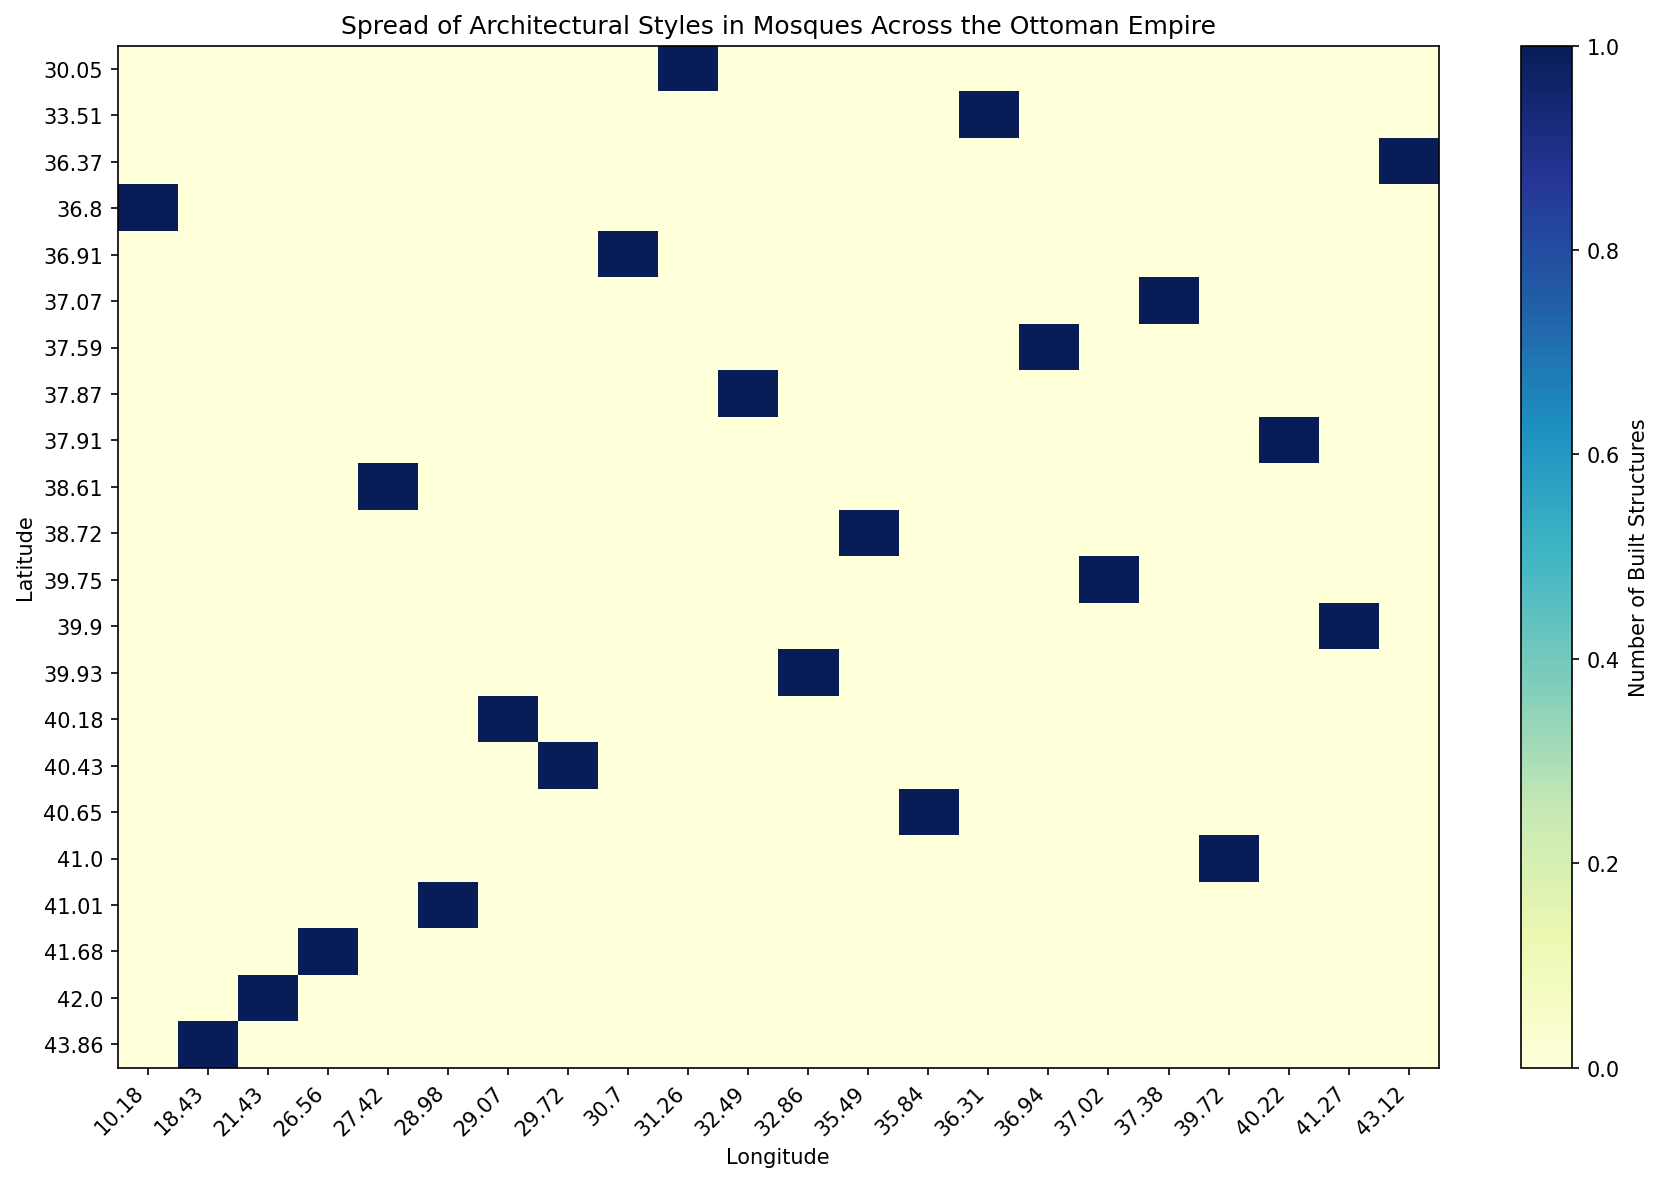What's the city with the highest number of built structures in the 15th century? Locate the darkest (most-filled) cell corresponding to the 15th century on the heatmap, then identify the associated city on the Y-axis. Darker cells represent higher counts.
Answer: Istanbul How many built structures are there in the city with coordinates closest to 41.00 latitude and 29.00 longitude? Find the coordinates closest to 41.00 latitude and 29.00 longitude on the axes. Look at the intensity of the cell at this location to determine the count. The closest coordinates (approximately) are (41.00 latitude, 28.98 longitude) for Istanbul, and you observe the cell color.
Answer: 1 Which city in the 13th century contributed to the spread of architectural styles? Identify the row corresponding to the 13th century and then look across the cells to find any highlighted cells, the Y-axis label of which gives the city.
Answer: Konya Compare the number of built structures in Ankara and Diyarbakir during the 15th century. Which one has more? Examine the cells corresponding to Ankara and Diyarbakir in the 15th-century row. Compare the colors to see which has a darker shade representing more built structures.
Answer: Diyarbakir What century has the highest concentration of built structures in cities near a latitude of 40.00? Identify the rows near the latitude of 40.00, then scan across to determine which row has the largest number of highlighted cells or the darker shades.
Answer: 15th century 